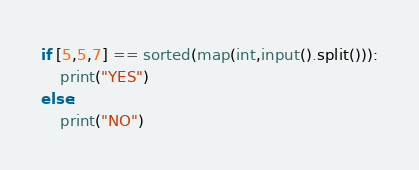Convert code to text. <code><loc_0><loc_0><loc_500><loc_500><_Python_>if [5,5,7] == sorted(map(int,input().split())):
    print("YES")
else:
    print("NO")
</code> 